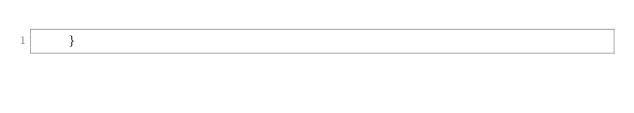Convert code to text. <code><loc_0><loc_0><loc_500><loc_500><_Go_>	}</code> 